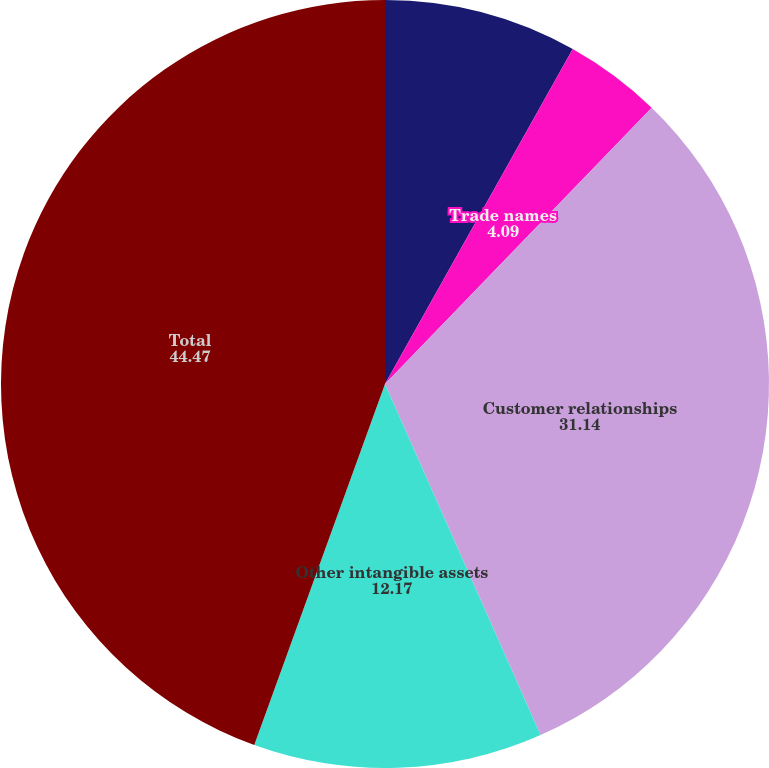<chart> <loc_0><loc_0><loc_500><loc_500><pie_chart><fcel>Patents and copyrights<fcel>Trade names<fcel>Customer relationships<fcel>Other intangible assets<fcel>Total<nl><fcel>8.13%<fcel>4.09%<fcel>31.14%<fcel>12.17%<fcel>44.47%<nl></chart> 